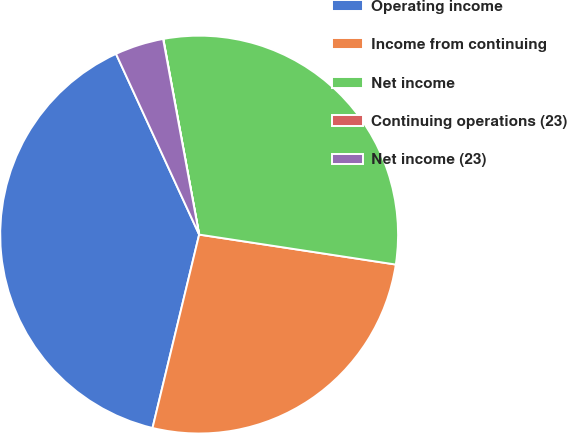<chart> <loc_0><loc_0><loc_500><loc_500><pie_chart><fcel>Operating income<fcel>Income from continuing<fcel>Net income<fcel>Continuing operations (23)<fcel>Net income (23)<nl><fcel>39.37%<fcel>26.36%<fcel>30.29%<fcel>0.02%<fcel>3.96%<nl></chart> 